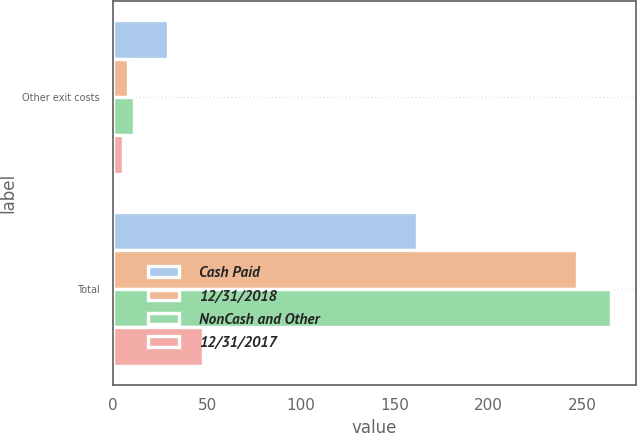Convert chart to OTSL. <chart><loc_0><loc_0><loc_500><loc_500><stacked_bar_chart><ecel><fcel>Other exit costs<fcel>Total<nl><fcel>Cash Paid<fcel>29<fcel>162<nl><fcel>12/31/2018<fcel>8<fcel>247<nl><fcel>NonCash and Other<fcel>11<fcel>265<nl><fcel>12/31/2017<fcel>5<fcel>48<nl></chart> 